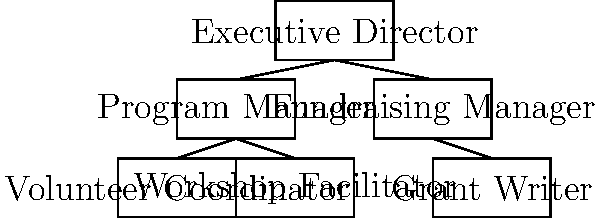In the organizational chart shown, who does the Workshop Facilitator report directly to? To determine who the Workshop Facilitator reports to, we need to follow these steps:

1. Locate the "Workshop Facilitator" box in the organizational chart.
2. Look for the line connecting the Workshop Facilitator box to the box above it.
3. Identify the box directly above the Workshop Facilitator that is connected by this line.
4. The label in this box indicates the person or role to whom the Workshop Facilitator reports.

Following these steps:
1. We can see the "Workshop Facilitator" box at the bottom left of the chart.
2. There is a line connecting this box to the box above it.
3. The box directly above, connected by this line, is labeled "Program Manager".
4. Therefore, the Workshop Facilitator reports directly to the Program Manager.

This structure is common in non-profit organizations, where program-related roles often report to a Program Manager, who then reports to the Executive Director.
Answer: Program Manager 